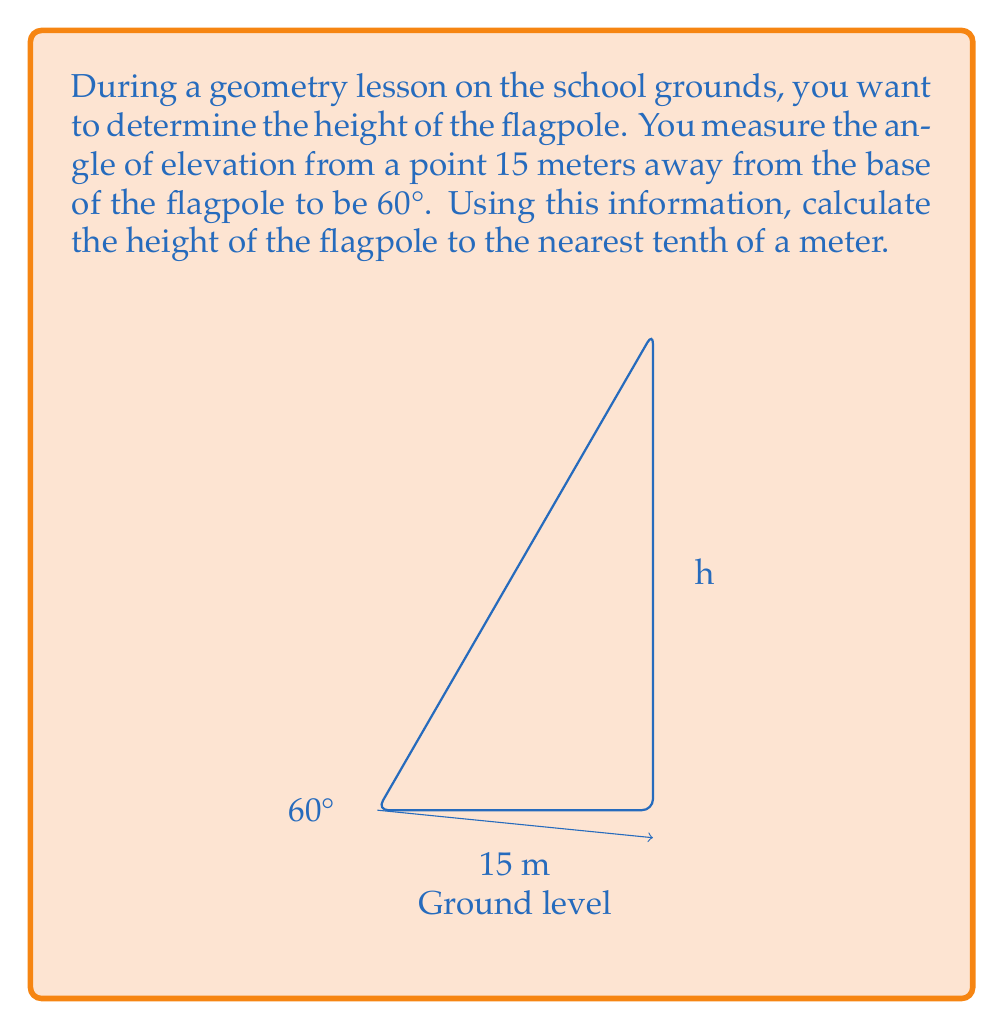Show me your answer to this math problem. Let's approach this step-by-step using trigonometry:

1) In this problem, we have a right triangle where:
   - The adjacent side is 15 meters (distance from the observer to the base of the flagpole)
   - The angle of elevation is 60°
   - We need to find the opposite side (height of the flagpole)

2) For right triangles, we use the tangent function to relate the opposite side to the adjacent side:

   $$\tan(\theta) = \frac{\text{opposite}}{\text{adjacent}}$$

3) In this case:
   $$\tan(60°) = \frac{\text{height}}{15}$$

4) We know that $\tan(60°) = \sqrt{3}$, so we can write:
   $$\sqrt{3} = \frac{\text{height}}{15}$$

5) To solve for the height, multiply both sides by 15:
   $$15\sqrt{3} = \text{height}$$

6) Calculate the value:
   $$15 * 1.732050808 \approx 25.98076211$$

7) Rounding to the nearest tenth:
   $$25.98076211 \approx 26.0$$

Therefore, the height of the flagpole is approximately 26.0 meters.
Answer: 26.0 m 